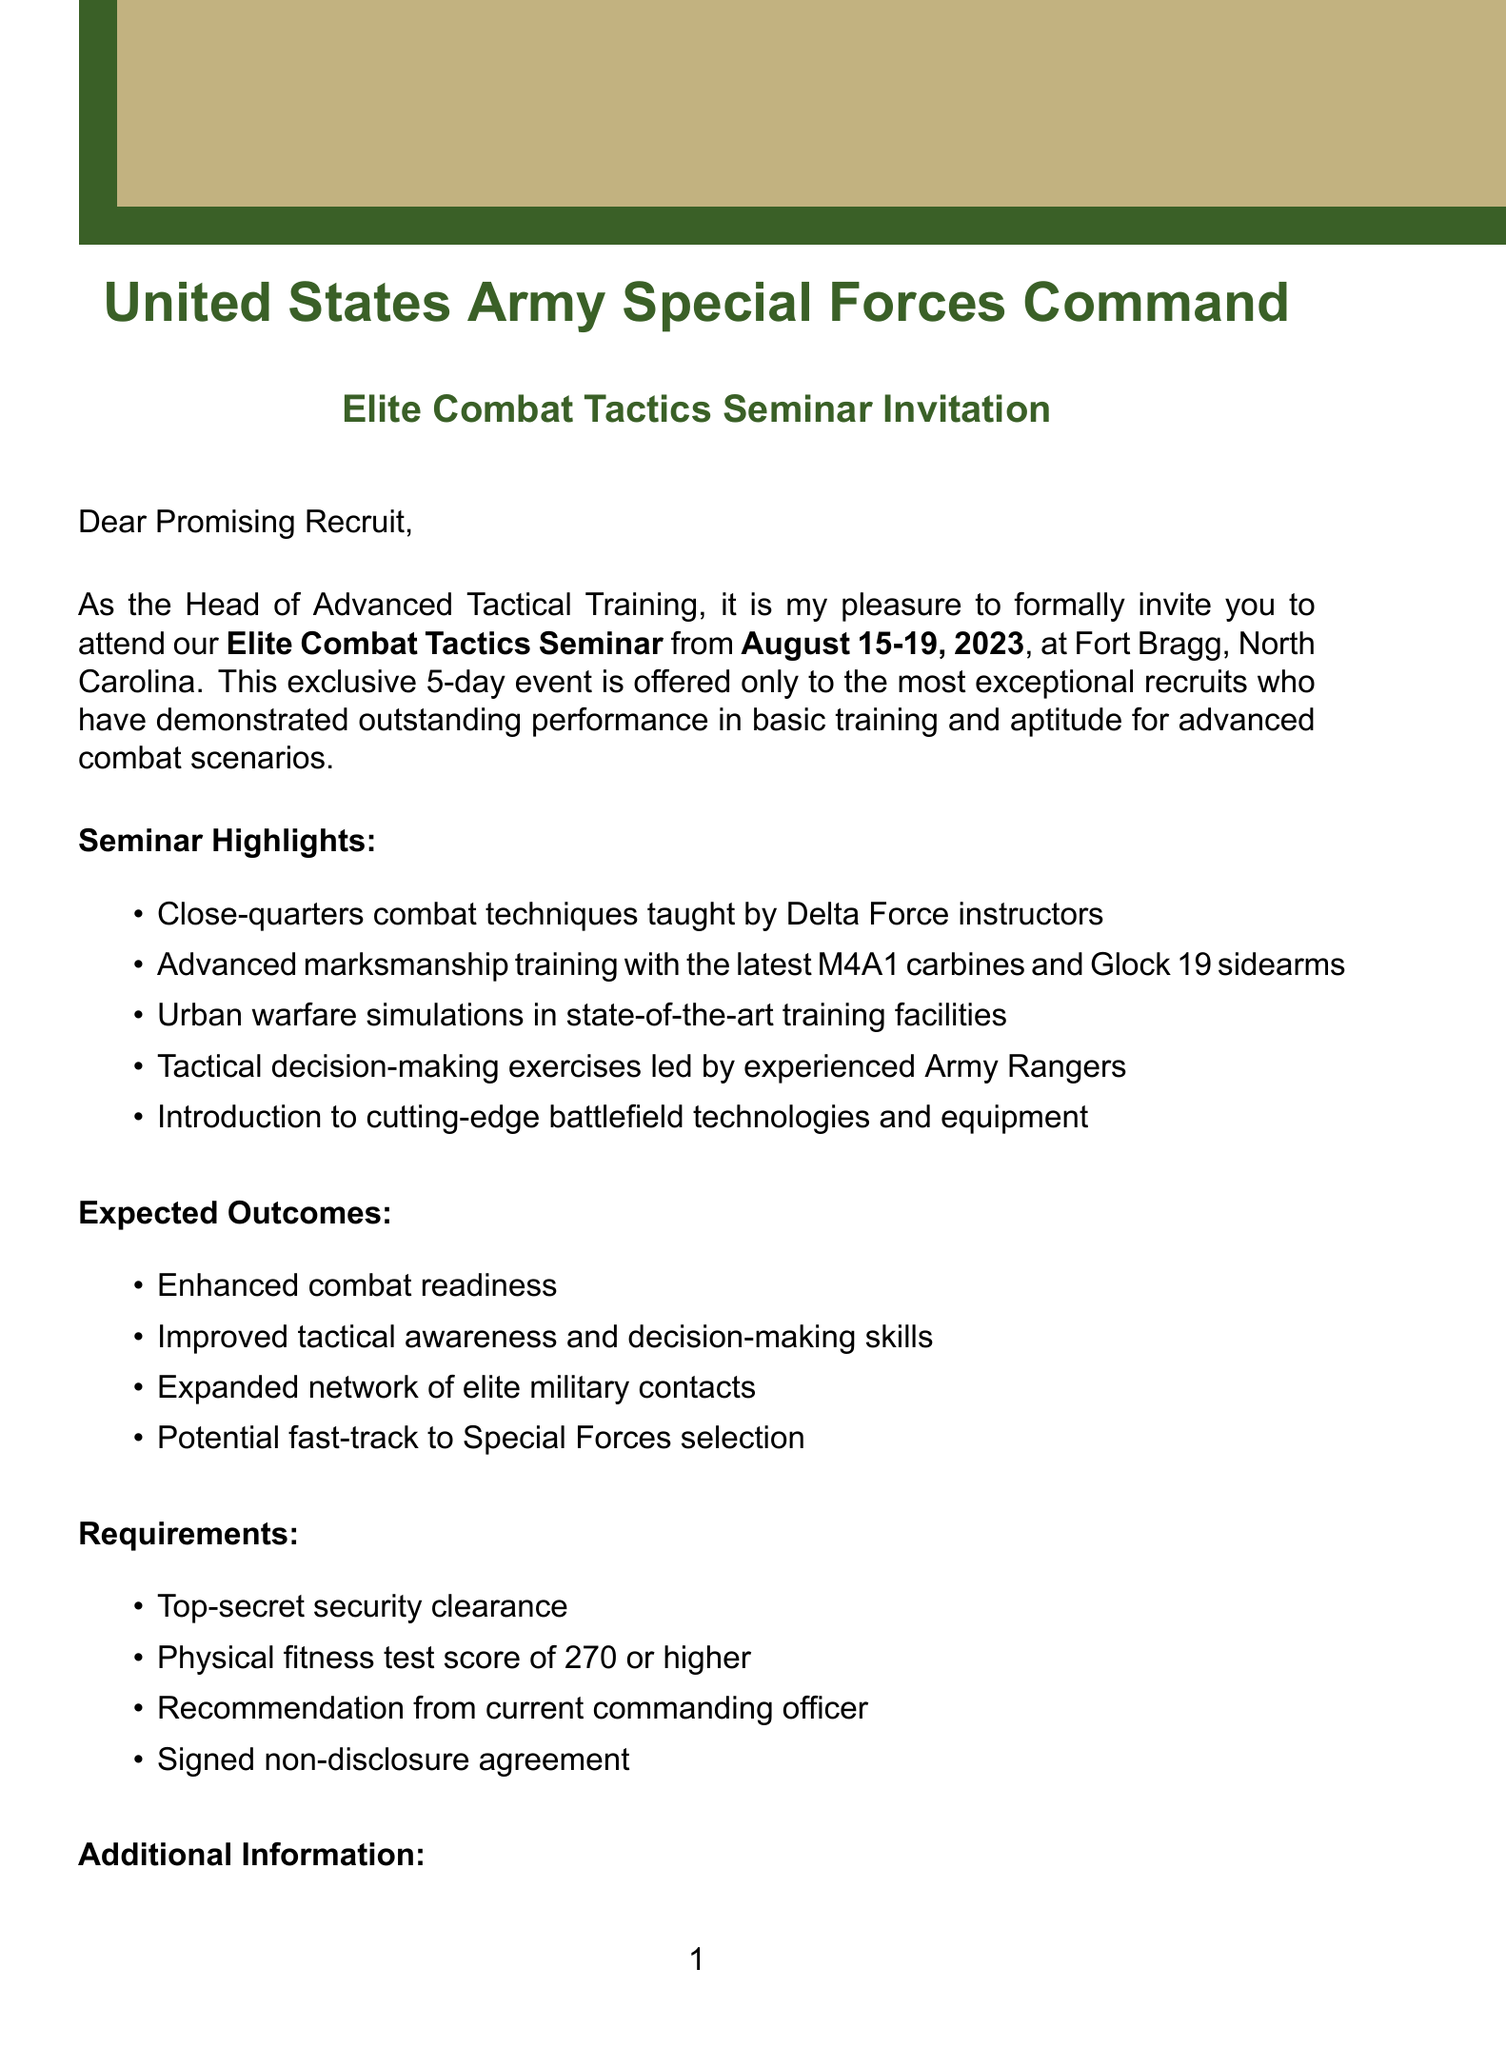What is the name of the seminar? The name of the seminar is stated in the event details section of the document, which is the "Elite Combat Tactics Seminar."
Answer: Elite Combat Tactics Seminar Who is the sender of the invitation? The document identifies Colonel Sarah Thompson as the sender, who is the Head of Advanced Tactical Training.
Answer: Colonel Sarah Thompson What are the dates of the seminar? The dates of the seminar are specified in the event details section as August 15-19, 2023.
Answer: August 15-19, 2023 What is the physical fitness test score requirement? The requirement for physical fitness test score is stated in the requirements section of the document as 270 or higher.
Answer: 270 or higher What is provided for accommodation? The additional information section specifies that on-base housing is provided during the seminar.
Answer: On-base housing What is the RSVP deadline? The deadline for RSVP is mentioned in the contact section, which is July 31, 2023.
Answer: July 31, 2023 Why is this seminar being offered? The invitation reason outlines that it is offered due to outstanding performance in basic training and aptitude for advanced combat scenarios.
Answer: Outstanding performance in basic training What is one of the expected outcomes of attending the seminar? The expected outcomes section lists several benefits, one being enhanced combat readiness.
Answer: Enhanced combat readiness What dress code is required for the seminar? The additional information section states that the dress code for all sessions is ACU (Army Combat Uniform).
Answer: ACU (Army Combat Uniform) 